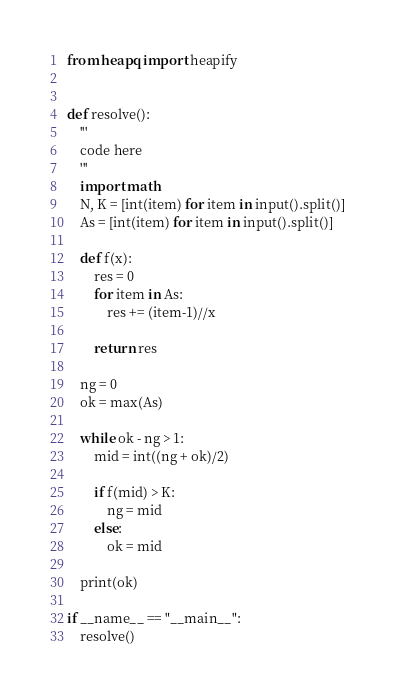Convert code to text. <code><loc_0><loc_0><loc_500><loc_500><_Python_>from heapq import heapify


def resolve():
    '''
    code here
    '''
    import math
    N, K = [int(item) for item in input().split()]
    As = [int(item) for item in input().split()]

    def f(x):
        res = 0
        for item in As:
            res += (item-1)//x

        return res

    ng = 0
    ok = max(As)

    while ok - ng > 1:
        mid = int((ng + ok)/2)

        if f(mid) > K:
            ng = mid
        else:
            ok = mid
            
    print(ok)

if __name__ == "__main__":
    resolve()
</code> 